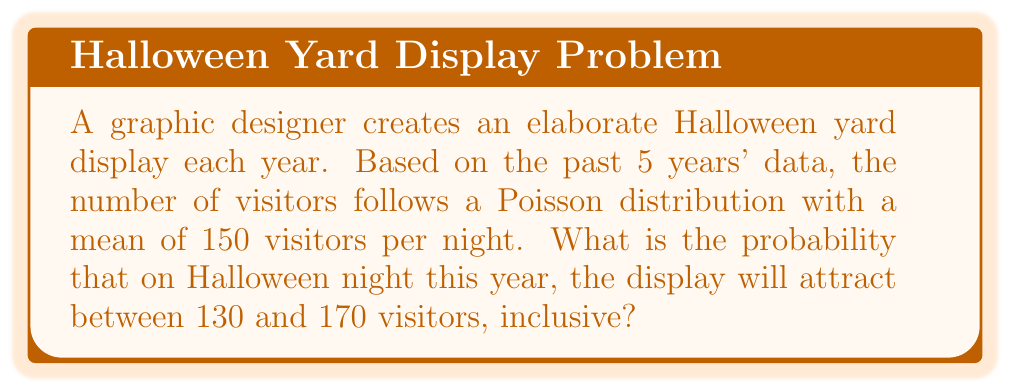What is the answer to this math problem? To solve this problem, we'll use the Poisson distribution and its cumulative distribution function (CDF).

1) The Poisson distribution has a probability mass function:

   $$P(X = k) = \frac{e^{-\lambda}\lambda^k}{k!}$$

   where $\lambda$ is the mean number of events in the interval.

2) We need to find $P(130 \leq X \leq 170)$, where $X$ is the number of visitors and $\lambda = 150$.

3) This can be calculated as:

   $$P(130 \leq X \leq 170) = P(X \leq 170) - P(X \leq 129)$$

4) For large $\lambda$ (like 150), the Poisson distribution can be approximated by a normal distribution with mean $\mu = \lambda$ and variance $\sigma^2 = \lambda$.

5) Using this approximation:

   $$Z = \frac{X - \lambda}{\sqrt{\lambda}}$$

6) For $X = 170$ and $X = 129$:

   $$Z_{170} = \frac{170 - 150}{\sqrt{150}} \approx 1.63$$
   $$Z_{129} = \frac{129 - 150}{\sqrt{150}} \approx -1.71$$

7) Using a standard normal distribution table or calculator:

   $$P(X \leq 170) \approx P(Z \leq 1.63) \approx 0.9484$$
   $$P(X \leq 129) \approx P(Z \leq -1.71) \approx 0.0436$$

8) Therefore:

   $$P(130 \leq X \leq 170) \approx 0.9484 - 0.0436 = 0.9048$$
Answer: $0.9048$ or $90.48\%$ 